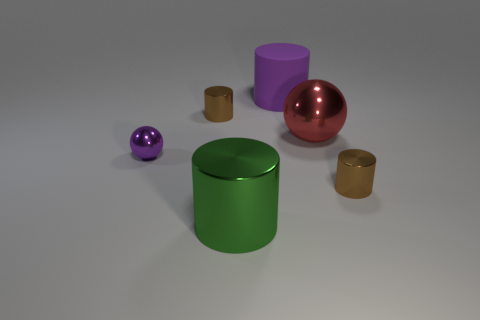Subtract all green metal cylinders. How many cylinders are left? 3 Subtract all cyan blocks. How many brown cylinders are left? 2 Add 4 purple things. How many objects exist? 10 Subtract all green cylinders. How many cylinders are left? 3 Subtract 2 cylinders. How many cylinders are left? 2 Subtract all cylinders. How many objects are left? 2 Subtract all big matte cylinders. Subtract all rubber things. How many objects are left? 4 Add 3 red spheres. How many red spheres are left? 4 Add 4 red spheres. How many red spheres exist? 5 Subtract 0 red blocks. How many objects are left? 6 